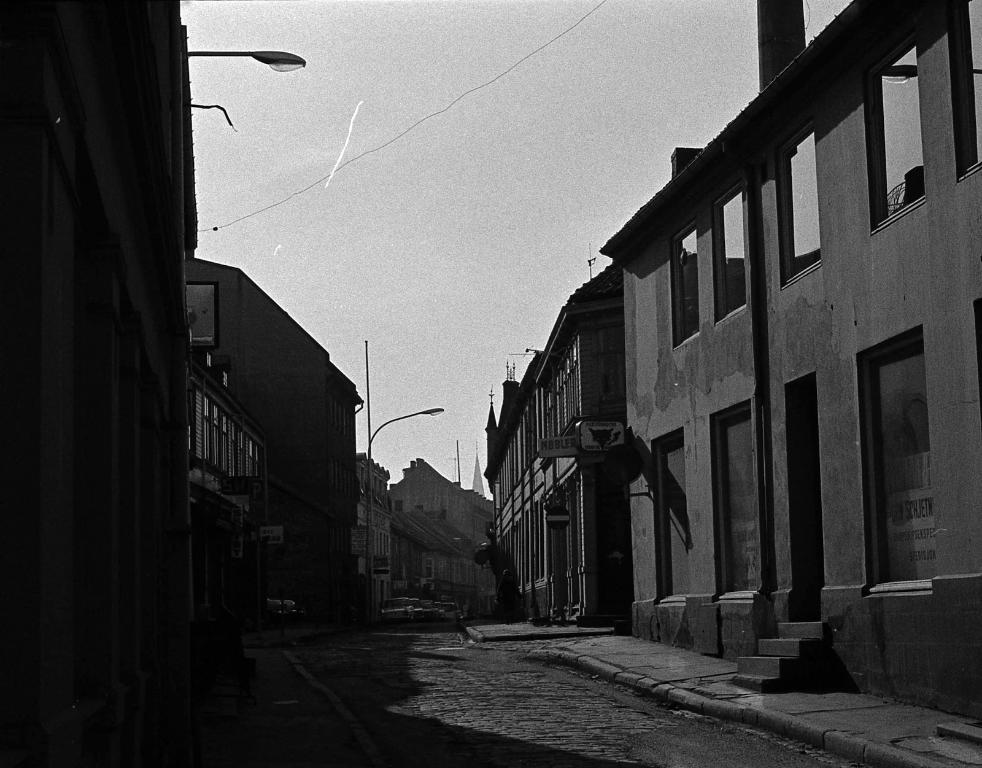What type of structures can be seen in the image? There are buildings in the image. What else can be seen in the image besides buildings? There are electrical poles and sign boards in the image. What is the condition of the sky in the image? The sky is cloudy in the image. Can you see a plane flying in the image? There is no plane visible in the image. Is there a tree present in the image? There is no tree present in the image. 